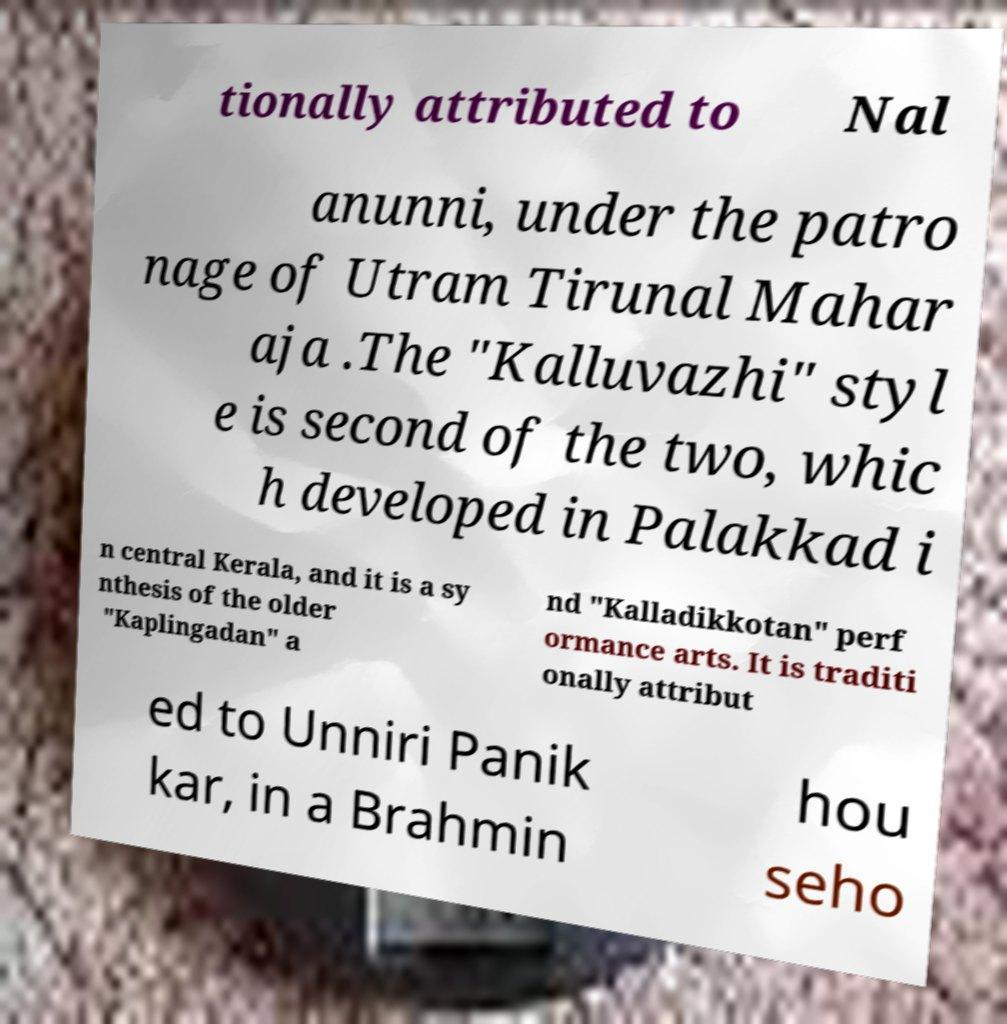Could you extract and type out the text from this image? tionally attributed to Nal anunni, under the patro nage of Utram Tirunal Mahar aja .The "Kalluvazhi" styl e is second of the two, whic h developed in Palakkad i n central Kerala, and it is a sy nthesis of the older "Kaplingadan" a nd "Kalladikkotan" perf ormance arts. It is traditi onally attribut ed to Unniri Panik kar, in a Brahmin hou seho 